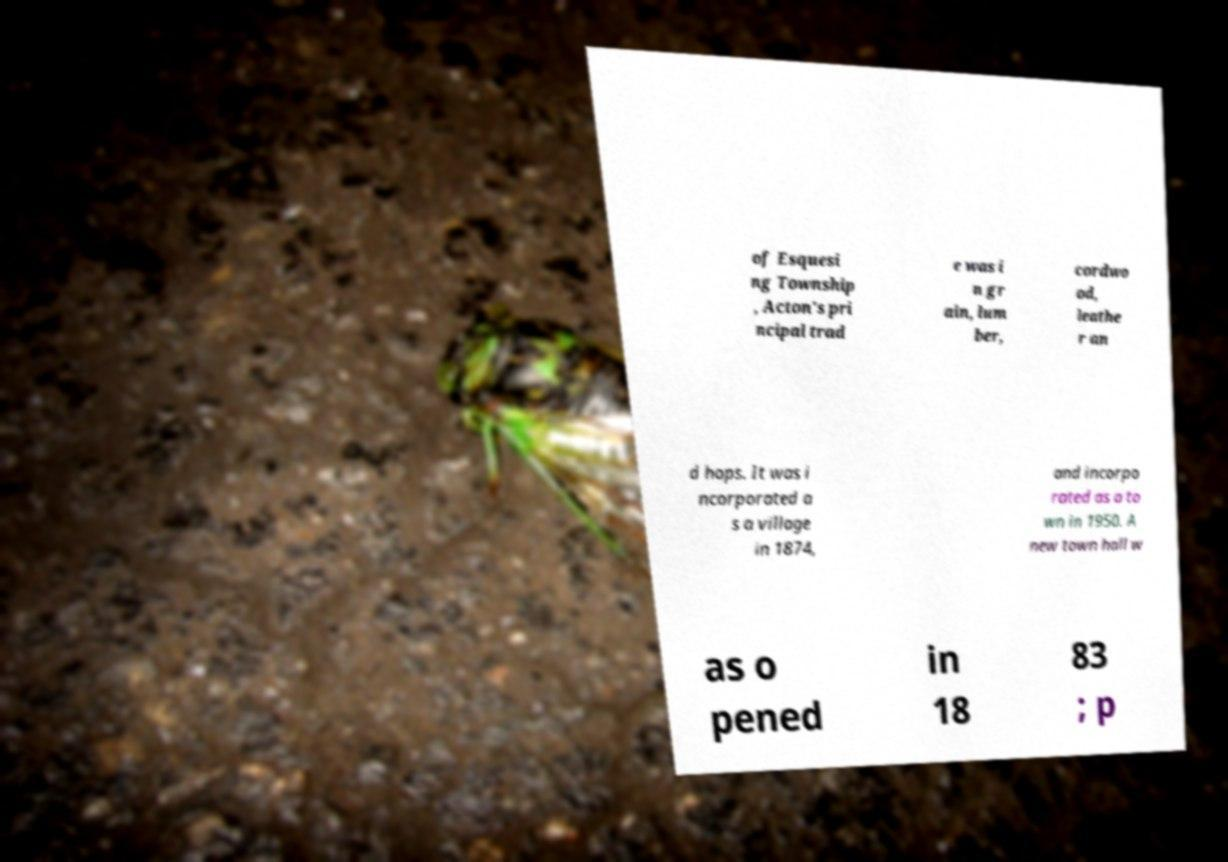Can you read and provide the text displayed in the image?This photo seems to have some interesting text. Can you extract and type it out for me? of Esquesi ng Township , Acton's pri ncipal trad e was i n gr ain, lum ber, cordwo od, leathe r an d hops. It was i ncorporated a s a village in 1874, and incorpo rated as a to wn in 1950. A new town hall w as o pened in 18 83 ; p 